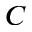<formula> <loc_0><loc_0><loc_500><loc_500>C</formula> 